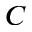<formula> <loc_0><loc_0><loc_500><loc_500>C</formula> 